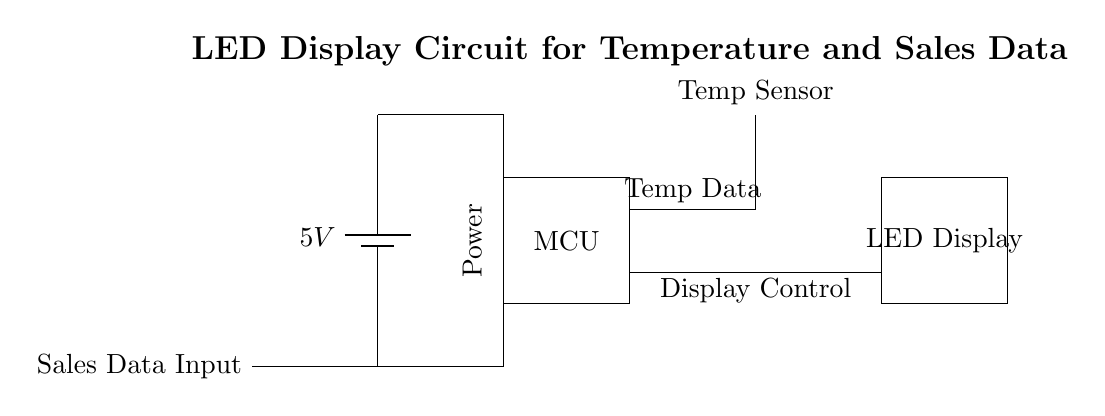What is the voltage of this circuit? The voltage is 5V, which is stated next to the battery symbol, indicating the power supply voltage for the circuit.
Answer: 5V What component is responsible for temperature measurement? The component labeled as "Temp Sensor" in the diagram is found at the top, indicating it is a thermistor or similar sensor designed to measure temperature.
Answer: Temp Sensor What type of microcontroller is used in this circuit? The circuit diagram labels this component simply as "MCU," which is an abbreviation for microcontroller, but does not specify the exact type.
Answer: MCU How are the sales data and temperature data connected in the circuit? The circuit shows direct connections between the sales data input, the microcontroller, and the temperature sensor, which indicates that the MCU processes both temperature and sales data.
Answer: Directly connected What is the function of the LED display in this circuit? The LED display serves to visually present the processed data from the microcontroller, specifically showing real-time temperature and sales figures to the user.
Answer: Data display What is the power source for the circuit? The power source for this circuit is a battery, which is indicated by the battery symbol at the left side of the diagram, supplying 5V to the entire circuit.
Answer: Battery What kind of data does this circuit handle besides temperature? Besides temperature, the circuit also processes sales data, as described by the label "Sales Data Input" on the left side of the diagram.
Answer: Sales data 